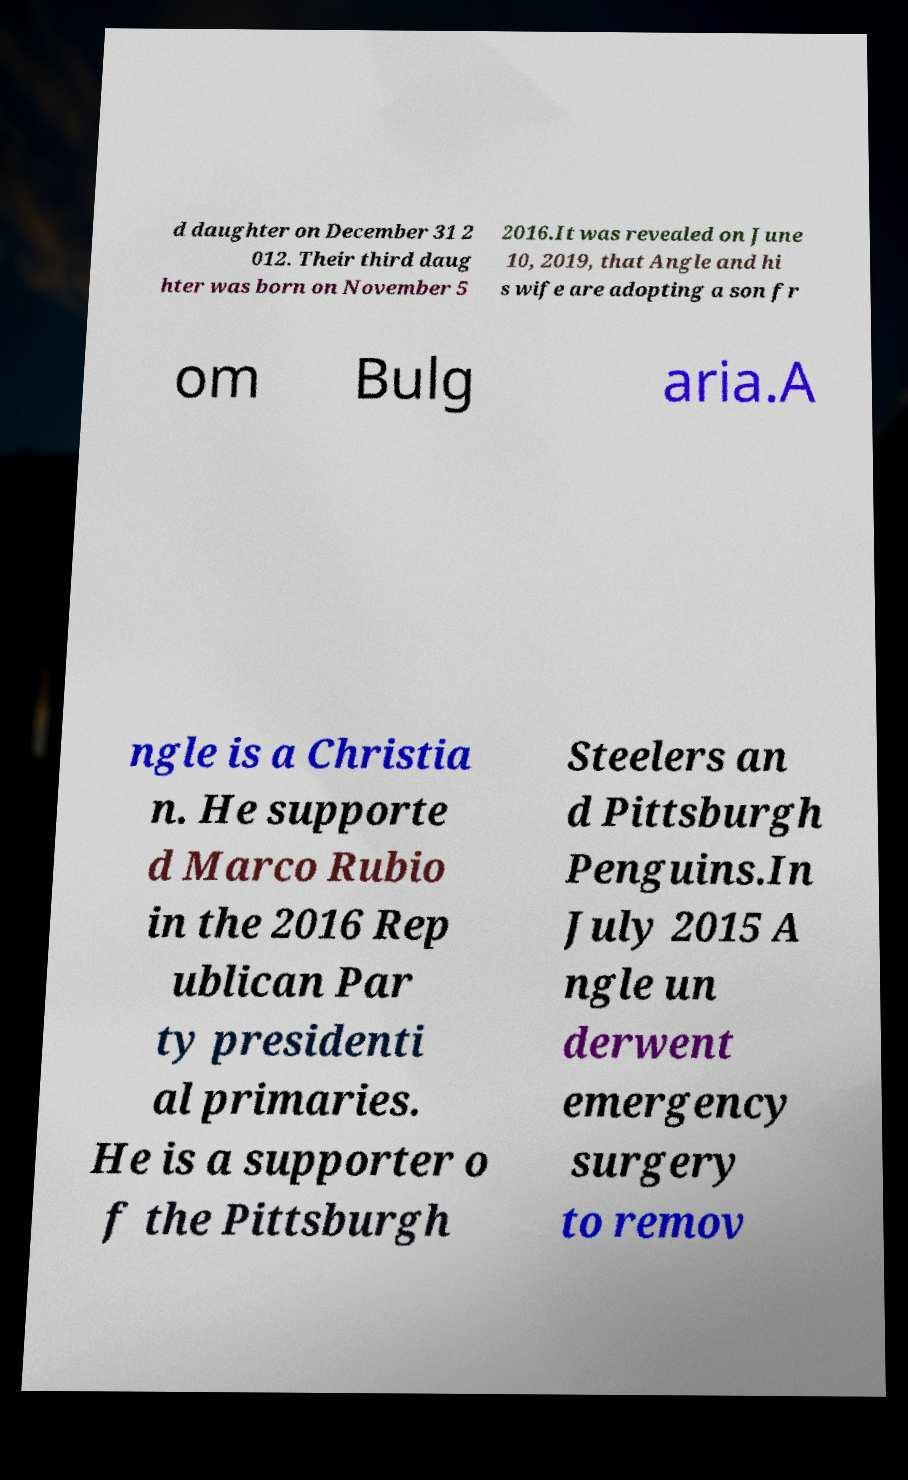Please read and relay the text visible in this image. What does it say? d daughter on December 31 2 012. Their third daug hter was born on November 5 2016.It was revealed on June 10, 2019, that Angle and hi s wife are adopting a son fr om Bulg aria.A ngle is a Christia n. He supporte d Marco Rubio in the 2016 Rep ublican Par ty presidenti al primaries. He is a supporter o f the Pittsburgh Steelers an d Pittsburgh Penguins.In July 2015 A ngle un derwent emergency surgery to remov 